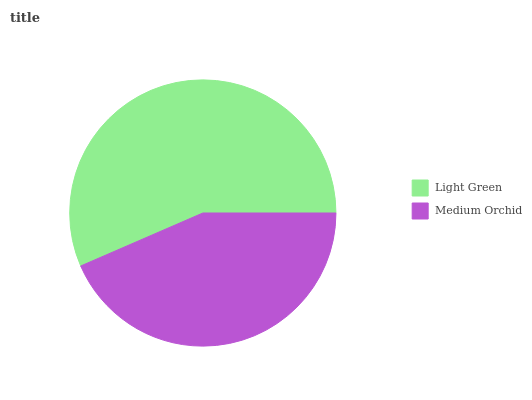Is Medium Orchid the minimum?
Answer yes or no. Yes. Is Light Green the maximum?
Answer yes or no. Yes. Is Medium Orchid the maximum?
Answer yes or no. No. Is Light Green greater than Medium Orchid?
Answer yes or no. Yes. Is Medium Orchid less than Light Green?
Answer yes or no. Yes. Is Medium Orchid greater than Light Green?
Answer yes or no. No. Is Light Green less than Medium Orchid?
Answer yes or no. No. Is Light Green the high median?
Answer yes or no. Yes. Is Medium Orchid the low median?
Answer yes or no. Yes. Is Medium Orchid the high median?
Answer yes or no. No. Is Light Green the low median?
Answer yes or no. No. 